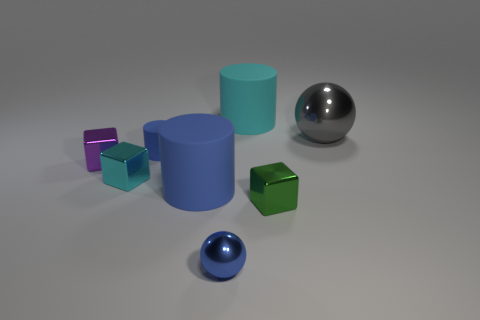Add 1 rubber cylinders. How many objects exist? 9 Subtract all balls. How many objects are left? 6 Add 4 small things. How many small things are left? 9 Add 7 big gray things. How many big gray things exist? 8 Subtract 1 cyan cylinders. How many objects are left? 7 Subtract all big cylinders. Subtract all tiny cyan blocks. How many objects are left? 5 